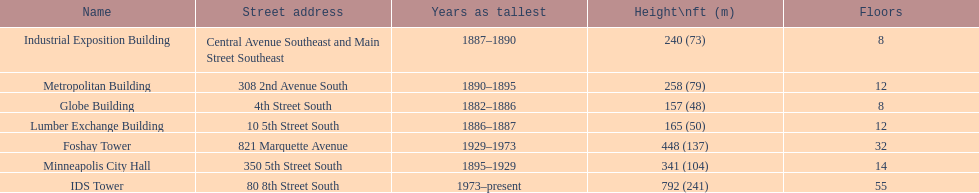How tall is it to the top of the ids tower in feet? 792. 